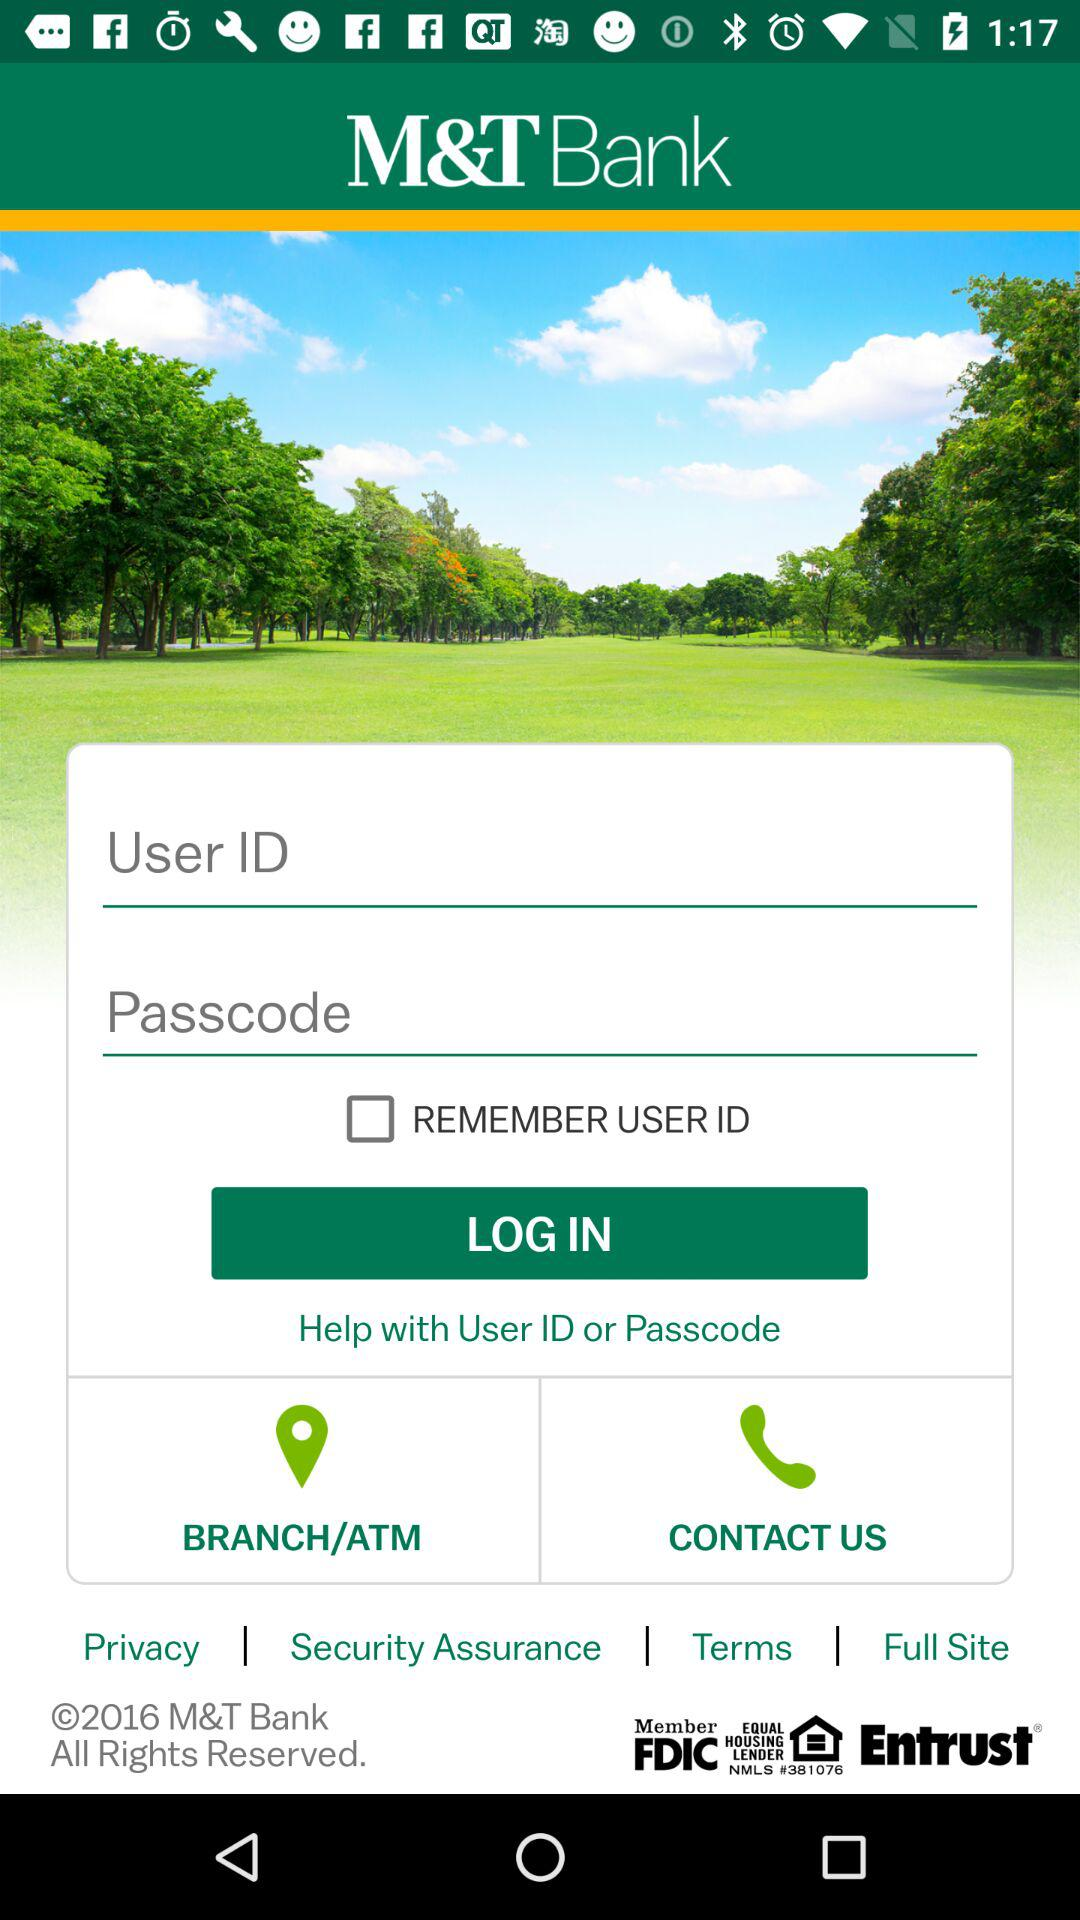What is the status of "REMEMBER USER ID"? The status is "off". 